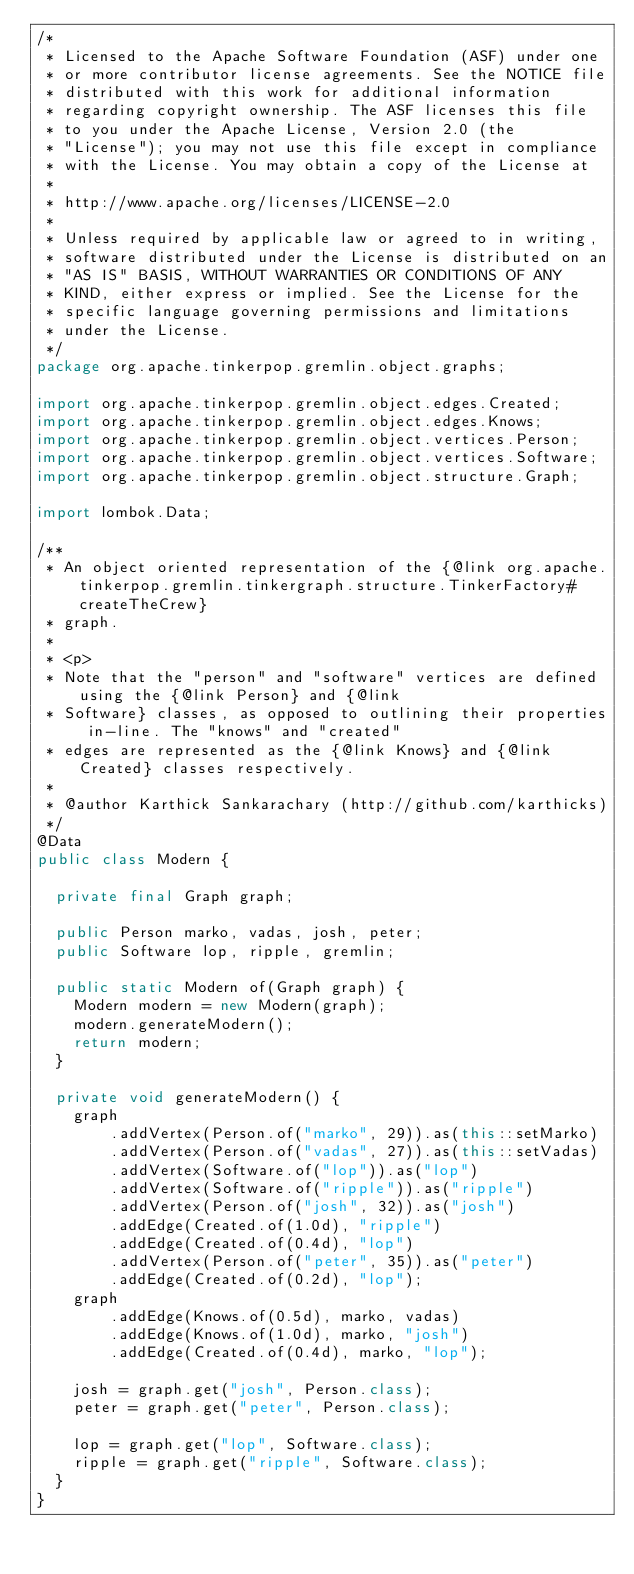<code> <loc_0><loc_0><loc_500><loc_500><_Java_>/*
 * Licensed to the Apache Software Foundation (ASF) under one
 * or more contributor license agreements. See the NOTICE file
 * distributed with this work for additional information
 * regarding copyright ownership. The ASF licenses this file
 * to you under the Apache License, Version 2.0 (the
 * "License"); you may not use this file except in compliance
 * with the License. You may obtain a copy of the License at
 * 
 * http://www.apache.org/licenses/LICENSE-2.0
 * 
 * Unless required by applicable law or agreed to in writing,
 * software distributed under the License is distributed on an
 * "AS IS" BASIS, WITHOUT WARRANTIES OR CONDITIONS OF ANY
 * KIND, either express or implied. See the License for the
 * specific language governing permissions and limitations
 * under the License.
 */
package org.apache.tinkerpop.gremlin.object.graphs;

import org.apache.tinkerpop.gremlin.object.edges.Created;
import org.apache.tinkerpop.gremlin.object.edges.Knows;
import org.apache.tinkerpop.gremlin.object.vertices.Person;
import org.apache.tinkerpop.gremlin.object.vertices.Software;
import org.apache.tinkerpop.gremlin.object.structure.Graph;

import lombok.Data;

/**
 * An object oriented representation of the {@link org.apache.tinkerpop.gremlin.tinkergraph.structure.TinkerFactory#createTheCrew}
 * graph.
 *
 * <p>
 * Note that the "person" and "software" vertices are defined using the {@link Person} and {@link
 * Software} classes, as opposed to outlining their properties in-line. The "knows" and "created"
 * edges are represented as the {@link Knows} and {@link Created} classes respectively.
 *
 * @author Karthick Sankarachary (http://github.com/karthicks)
 */
@Data
public class Modern {

  private final Graph graph;

  public Person marko, vadas, josh, peter;
  public Software lop, ripple, gremlin;

  public static Modern of(Graph graph) {
    Modern modern = new Modern(graph);
    modern.generateModern();
    return modern;
  }

  private void generateModern() {
    graph
        .addVertex(Person.of("marko", 29)).as(this::setMarko)
        .addVertex(Person.of("vadas", 27)).as(this::setVadas)
        .addVertex(Software.of("lop")).as("lop")
        .addVertex(Software.of("ripple")).as("ripple")
        .addVertex(Person.of("josh", 32)).as("josh")
        .addEdge(Created.of(1.0d), "ripple")
        .addEdge(Created.of(0.4d), "lop")
        .addVertex(Person.of("peter", 35)).as("peter")
        .addEdge(Created.of(0.2d), "lop");
    graph
        .addEdge(Knows.of(0.5d), marko, vadas)
        .addEdge(Knows.of(1.0d), marko, "josh")
        .addEdge(Created.of(0.4d), marko, "lop");

    josh = graph.get("josh", Person.class);
    peter = graph.get("peter", Person.class);

    lop = graph.get("lop", Software.class);
    ripple = graph.get("ripple", Software.class);
  }
}
</code> 